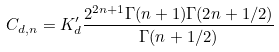<formula> <loc_0><loc_0><loc_500><loc_500>C _ { d , n } = K ^ { \prime } _ { d } \frac { 2 ^ { 2 n + 1 } \Gamma ( n + 1 ) \Gamma ( 2 n + 1 / 2 ) } { \Gamma ( n + 1 / 2 ) }</formula> 